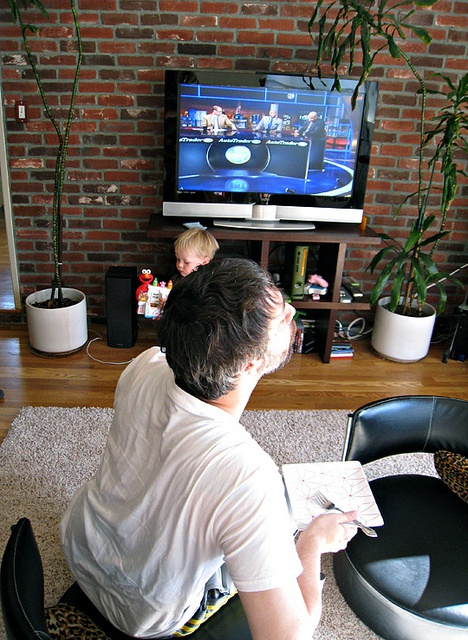Describe the objects in this image and their specific colors. I can see people in black, white, darkgray, and gray tones, potted plant in black, gray, and maroon tones, tv in black, white, and gray tones, chair in black, lightgray, gray, and blue tones, and chair in black, darkgreen, maroon, and gray tones in this image. 